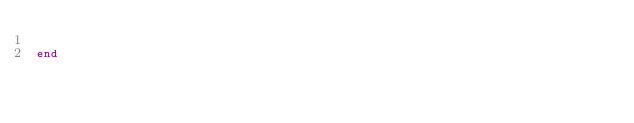Convert code to text. <code><loc_0><loc_0><loc_500><loc_500><_Elixir_>
end
</code> 